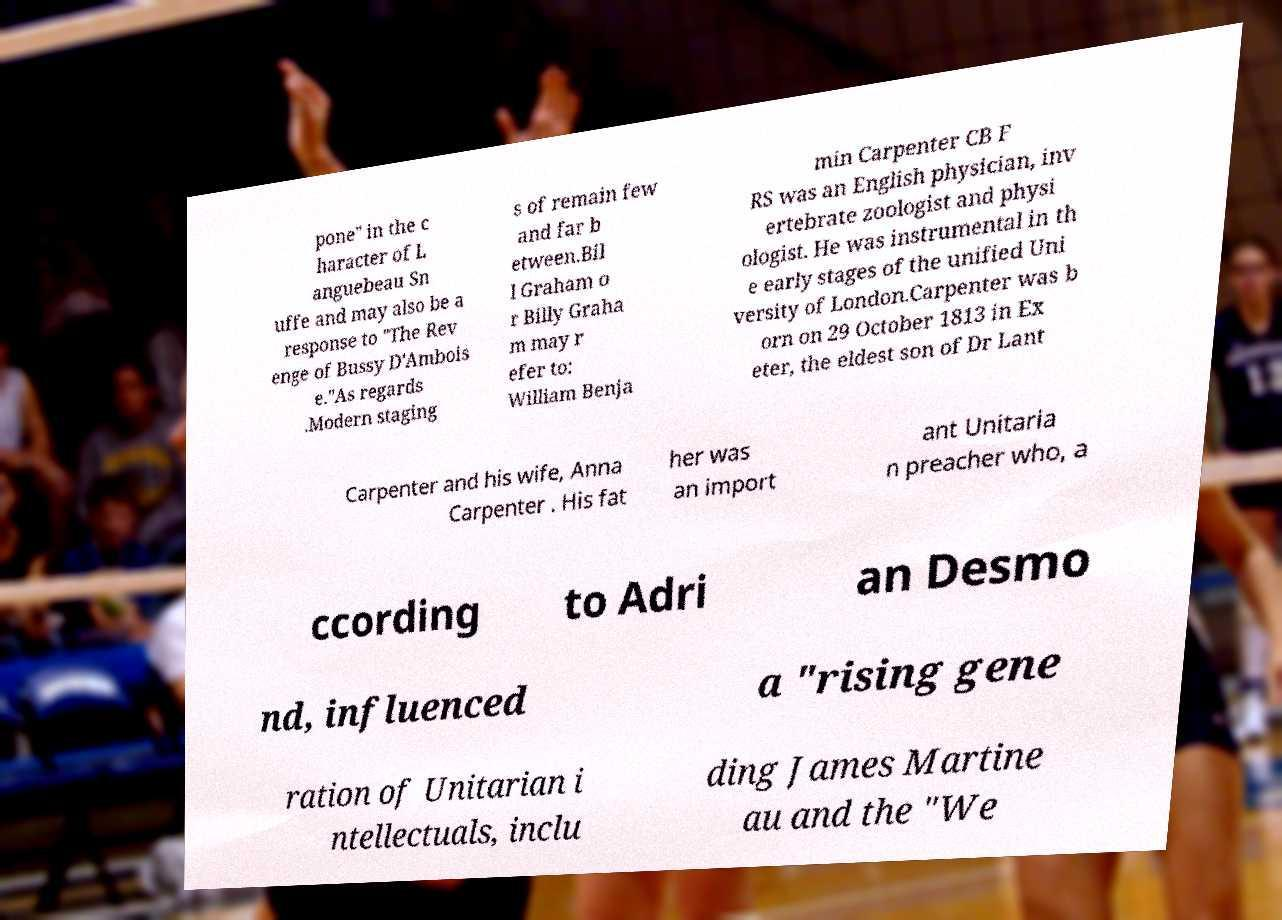Can you read and provide the text displayed in the image?This photo seems to have some interesting text. Can you extract and type it out for me? pone" in the c haracter of L anguebeau Sn uffe and may also be a response to "The Rev enge of Bussy D'Ambois e."As regards .Modern staging s of remain few and far b etween.Bil l Graham o r Billy Graha m may r efer to: William Benja min Carpenter CB F RS was an English physician, inv ertebrate zoologist and physi ologist. He was instrumental in th e early stages of the unified Uni versity of London.Carpenter was b orn on 29 October 1813 in Ex eter, the eldest son of Dr Lant Carpenter and his wife, Anna Carpenter . His fat her was an import ant Unitaria n preacher who, a ccording to Adri an Desmo nd, influenced a "rising gene ration of Unitarian i ntellectuals, inclu ding James Martine au and the "We 